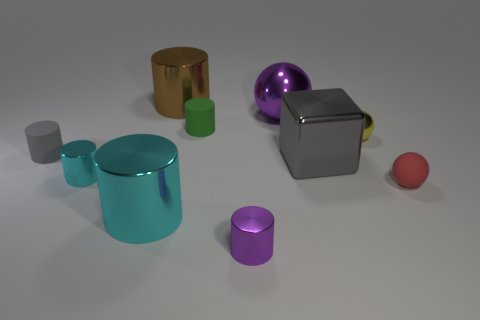There is a tiny metal cylinder that is on the right side of the tiny cyan metal thing; is its color the same as the rubber thing left of the green rubber object?
Make the answer very short. No. Is there a large brown cylinder?
Make the answer very short. Yes. There is a tiny cylinder that is the same color as the large cube; what is it made of?
Your answer should be very brief. Rubber. There is a purple metallic thing behind the small matte cylinder that is to the left of the large cylinder in front of the big brown shiny cylinder; how big is it?
Make the answer very short. Large. Do the small gray object and the purple metallic thing in front of the tiny matte ball have the same shape?
Your answer should be compact. Yes. Are there any metallic cubes that have the same color as the tiny matte ball?
Your answer should be compact. No. What number of spheres are either small green metallic objects or small cyan things?
Your response must be concise. 0. Are there any small cyan objects of the same shape as the big cyan thing?
Your answer should be compact. Yes. What number of other objects are there of the same color as the small metal sphere?
Make the answer very short. 0. Are there fewer gray matte objects that are in front of the small red matte object than large cyan metal balls?
Offer a very short reply. No. 